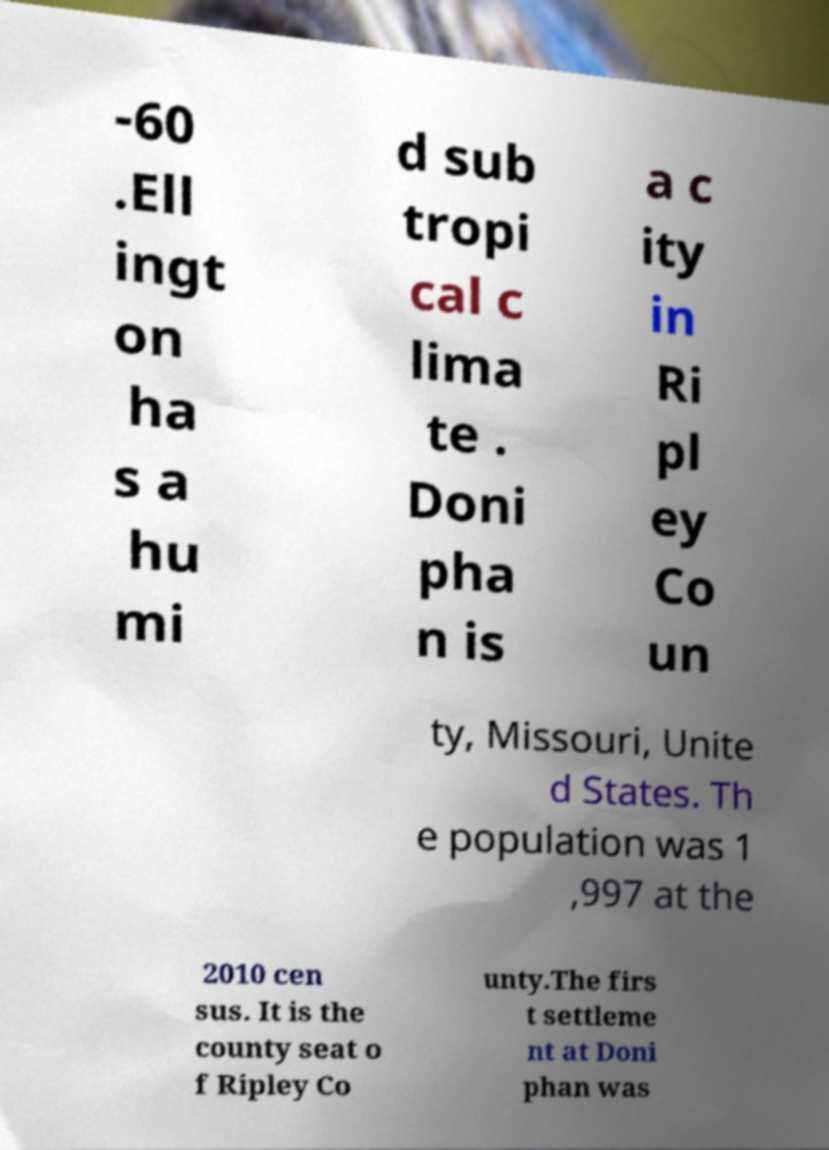Please identify and transcribe the text found in this image. -60 .Ell ingt on ha s a hu mi d sub tropi cal c lima te . Doni pha n is a c ity in Ri pl ey Co un ty, Missouri, Unite d States. Th e population was 1 ,997 at the 2010 cen sus. It is the county seat o f Ripley Co unty.The firs t settleme nt at Doni phan was 